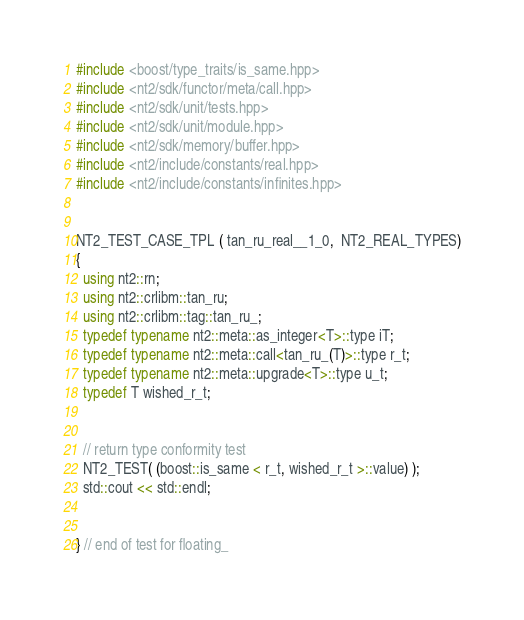<code> <loc_0><loc_0><loc_500><loc_500><_C++_>#include <boost/type_traits/is_same.hpp>
#include <nt2/sdk/functor/meta/call.hpp>
#include <nt2/sdk/unit/tests.hpp>
#include <nt2/sdk/unit/module.hpp>
#include <nt2/sdk/memory/buffer.hpp>
#include <nt2/include/constants/real.hpp>
#include <nt2/include/constants/infinites.hpp>


NT2_TEST_CASE_TPL ( tan_ru_real__1_0,  NT2_REAL_TYPES)
{
  using nt2::rn;
  using nt2::crlibm::tan_ru;
  using nt2::crlibm::tag::tan_ru_;
  typedef typename nt2::meta::as_integer<T>::type iT;
  typedef typename nt2::meta::call<tan_ru_(T)>::type r_t;
  typedef typename nt2::meta::upgrade<T>::type u_t;
  typedef T wished_r_t;


  // return type conformity test
  NT2_TEST( (boost::is_same < r_t, wished_r_t >::value) );
  std::cout << std::endl;


} // end of test for floating_
</code> 